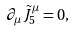<formula> <loc_0><loc_0><loc_500><loc_500>\partial _ { \mu } \tilde { J } _ { 5 } ^ { \mu } = 0 ,</formula> 